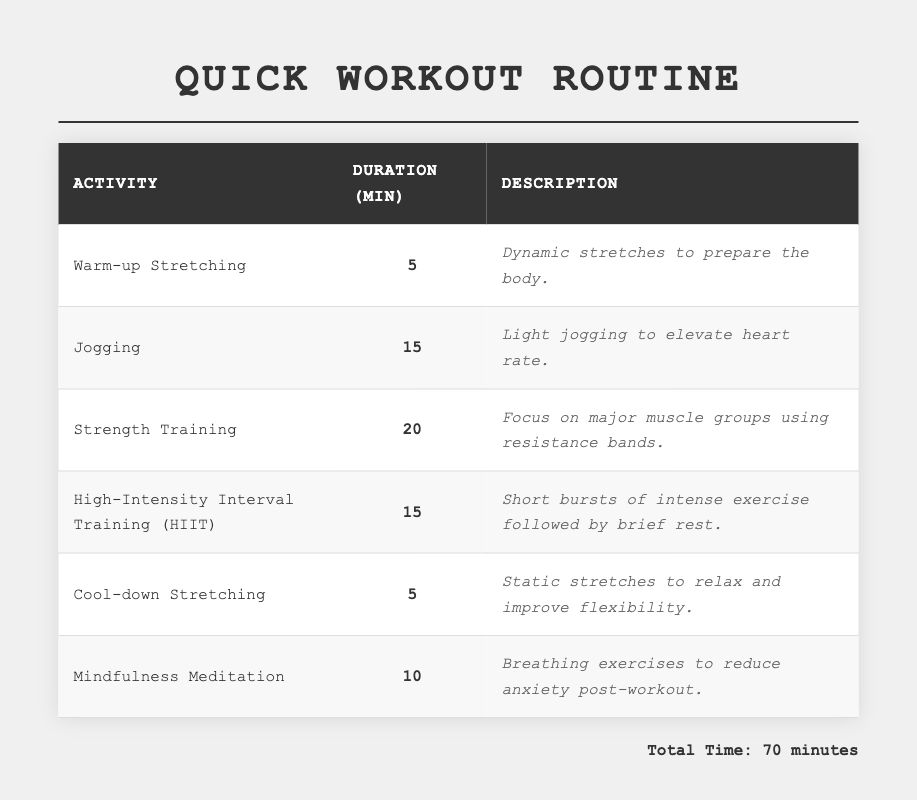What's the total duration of the exercise routine? To find the total duration, add all the individual durations together: 5 (Warm-up) + 15 (Jogging) + 20 (Strength Training) + 15 (HIIT) + 5 (Cool-down) + 10 (Meditation) = 70 minutes.
Answer: 70 minutes Which activity takes the longest time? Looking at the duration column, the activity with the highest duration of 20 minutes is Strength Training.
Answer: Strength Training How many minutes are dedicated to stretching activities combined? The stretching activities are Warm-up Stretching (5 minutes) and Cool-down Stretching (5 minutes). Adding these together gives 5 + 5 = 10 minutes dedicated to stretching.
Answer: 10 minutes Is there any activity that lasts less than 10 minutes? Reviewing the duration column reveals that both Warm-up Stretching (5 minutes) and Cool-down Stretching (5 minutes) are less than 10 minutes.
Answer: Yes What is the average duration of the activities? Calculate the average by summing the durations (70) and dividing by the number of activities (6): 70 / 6 = 11.67 minutes.
Answer: 11.67 minutes What proportion of the total time is spent on Mindfulness Meditation? Mindfulness Meditation lasts for 10 minutes out of a total of 70 minutes. To find the proportion, calculate 10/70 = 0.142857, which is approximately 14.29%.
Answer: 14.29% If a person skips the Cool-down Stretching, how much time will they save? The Cool-down Stretching lasts for 5 minutes. By skipping this activity, a person will save that amount of time.
Answer: 5 minutes What activities make up the second half of the routine? The second half of the routine includes High-Intensity Interval Training (15 minutes), Cool-down Stretching (5 minutes), and Mindfulness Meditation (10 minutes). Adding their durations confirms they fit within the remaining time.
Answer: HIIT, Cool-down Stretching, Mindfulness Meditation How many minutes are allocated to aerobic exercises? The aerobic exercises in this routine are Jogging (15 minutes) and HIIT (15 minutes). Combining these gives 15 + 15 = 30 minutes allocated to aerobic exercises.
Answer: 30 minutes If a person only has 30 minutes for a workout, which exercises can they fit in? If they have 30 minutes, they could fit Warm-up Stretching (5), Jogging (15), and Cool-down Stretching (5) or Warm-up (5), Jogging (15), and HIIT (15). Any combination of these that totals 30 or less will work.
Answer: Warm-up, Jogging, Cool-down or Warm-up, Jogging, HIIT 